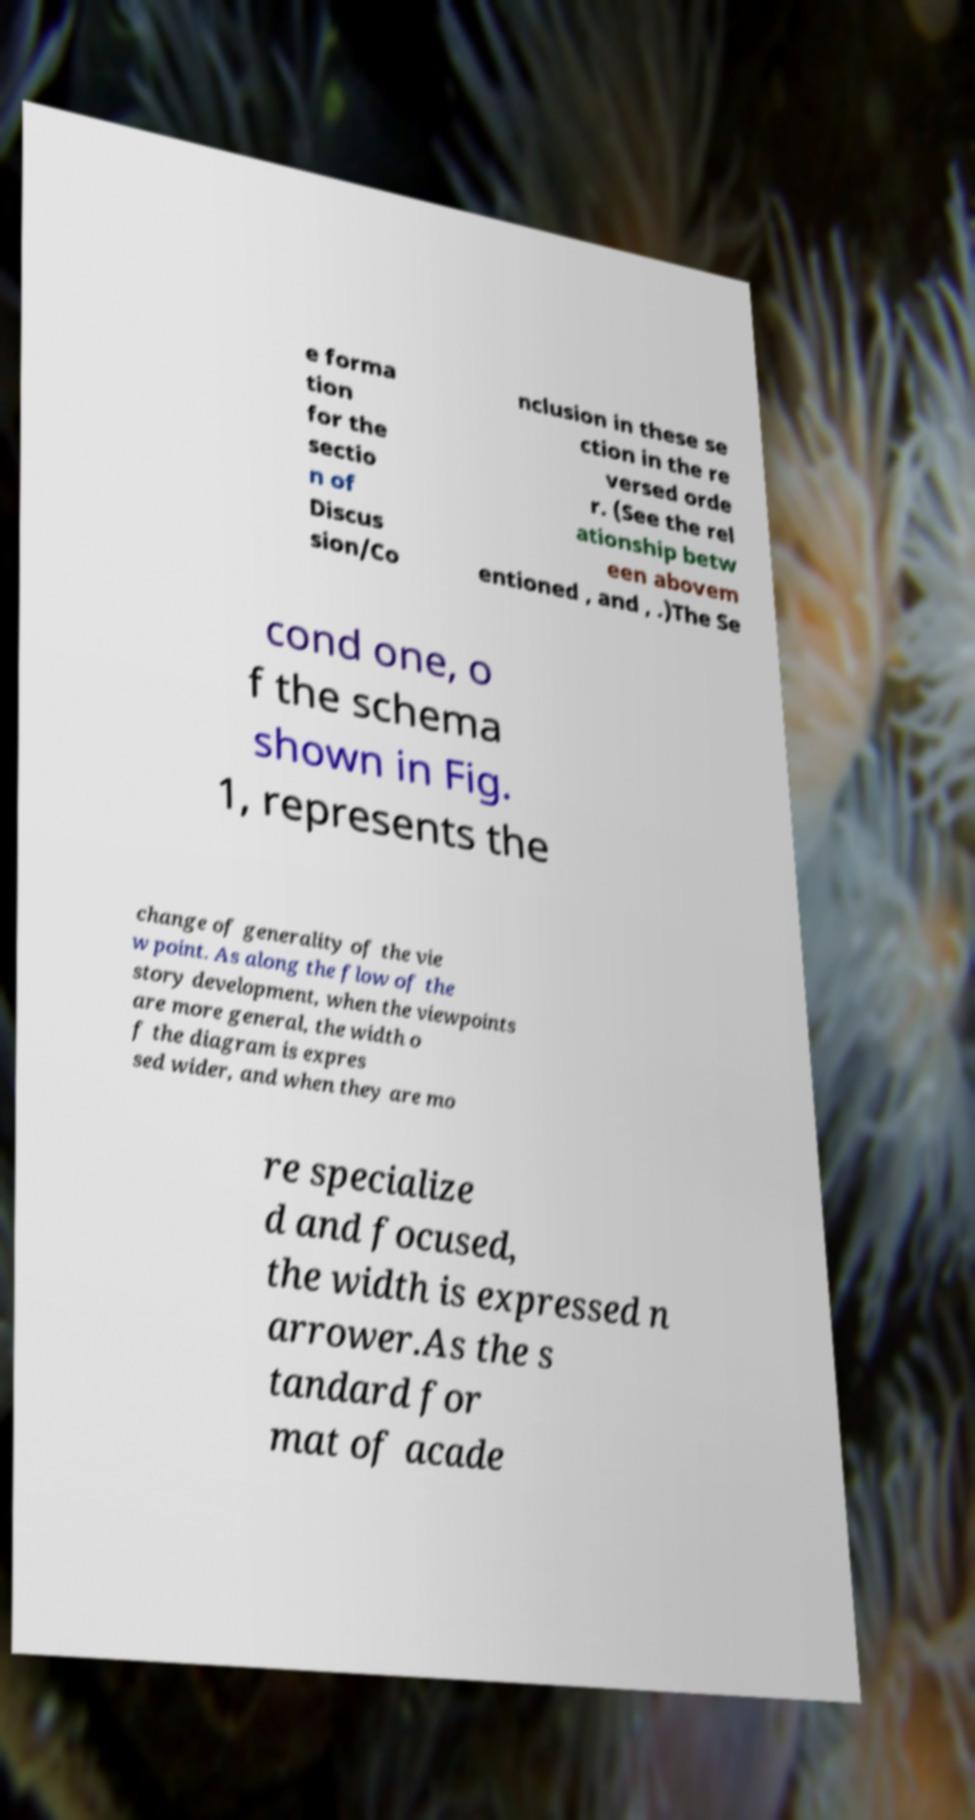For documentation purposes, I need the text within this image transcribed. Could you provide that? e forma tion for the sectio n of Discus sion/Co nclusion in these se ction in the re versed orde r. (See the rel ationship betw een abovem entioned , and , .)The Se cond one, o f the schema shown in Fig. 1, represents the change of generality of the vie w point. As along the flow of the story development, when the viewpoints are more general, the width o f the diagram is expres sed wider, and when they are mo re specialize d and focused, the width is expressed n arrower.As the s tandard for mat of acade 